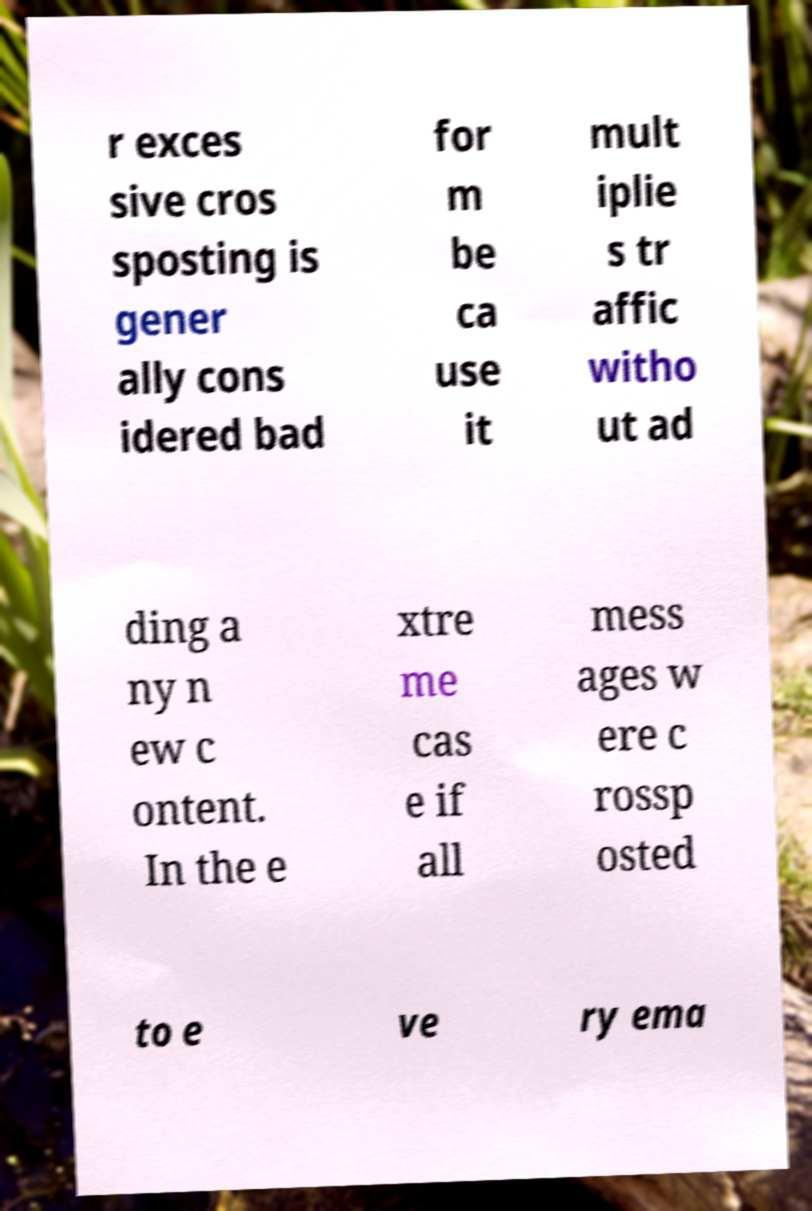For documentation purposes, I need the text within this image transcribed. Could you provide that? r exces sive cros sposting is gener ally cons idered bad for m be ca use it mult iplie s tr affic witho ut ad ding a ny n ew c ontent. In the e xtre me cas e if all mess ages w ere c rossp osted to e ve ry ema 